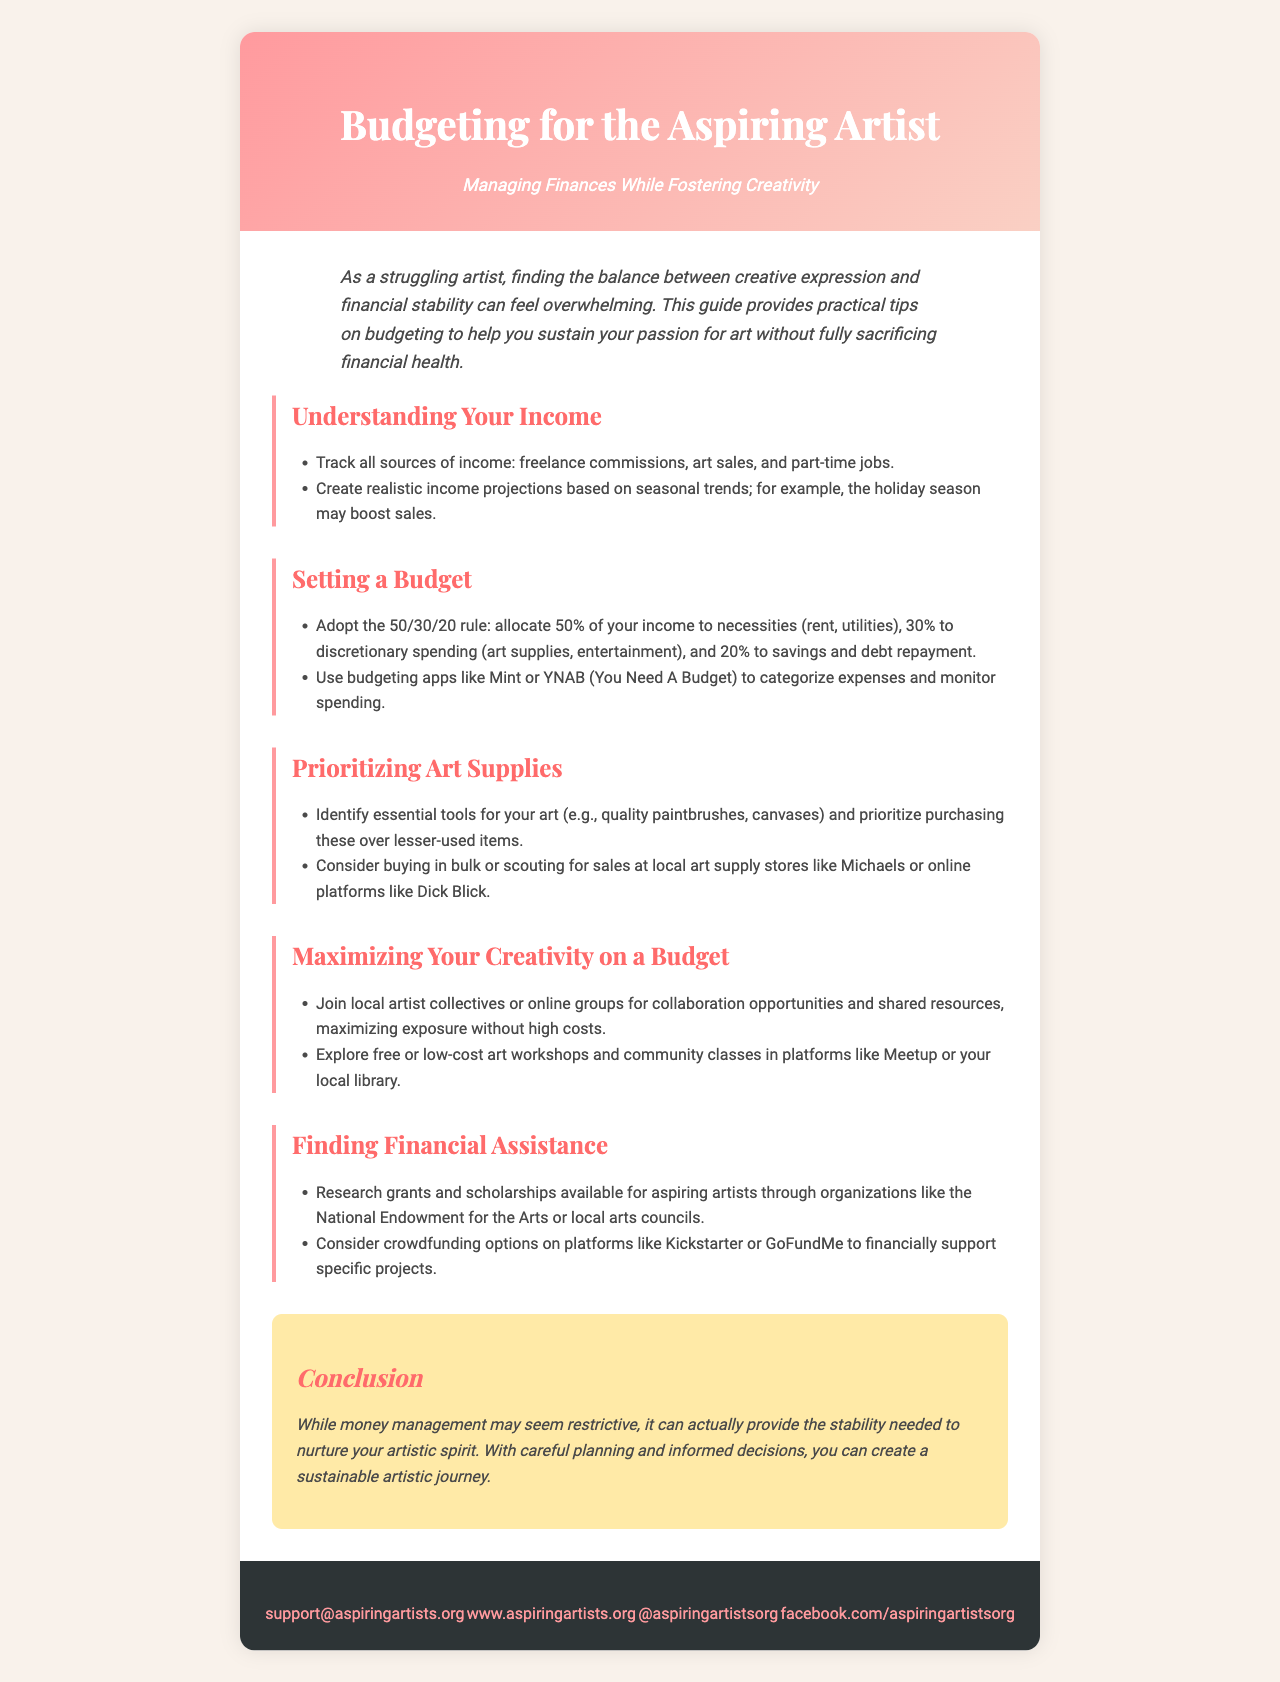What is the title of the brochure? The title is mentioned in the header section, specifically at the top of the document.
Answer: Budgeting for the Aspiring Artist What is the purpose of the brochure? The introduction highlights the main purpose of the brochure which is to help artists manage finances while fostering creativity.
Answer: Managing Finances While Fostering Creativity What budgeting method is recommended in the brochure? The document suggests an approach to budgeting that details how to allocate income across various categories.
Answer: 50/30/20 rule Which organization offers grants for aspiring artists? The brochure lists an organization known for providing assistance specifically for artists.
Answer: National Endowment for the Arts What are the suggested budgeting apps mentioned? The document includes examples of tools that can help artists keep track of their finances effectively.
Answer: Mint, YNAB What is one way to find financial assistance for artistic projects? The brochure provides a method besides grants to support specific artistic endeavors.
Answer: Crowdfunding options What section discusses maximizing creativity on a budget? The brochure outlines how artists can enhance their creative endeavors without spending much money.
Answer: Maximizing Your Creativity on a Budget What can artists do to prioritize their art supplies? The brochure advises on how to approach purchasing art materials effectively.
Answer: Identify essential tools What is included in the conclusion section? This section summarizes the overall message of the brochure focusing on financial management and its benefits for artists.
Answer: Stability needed to nurture your artistic spirit 